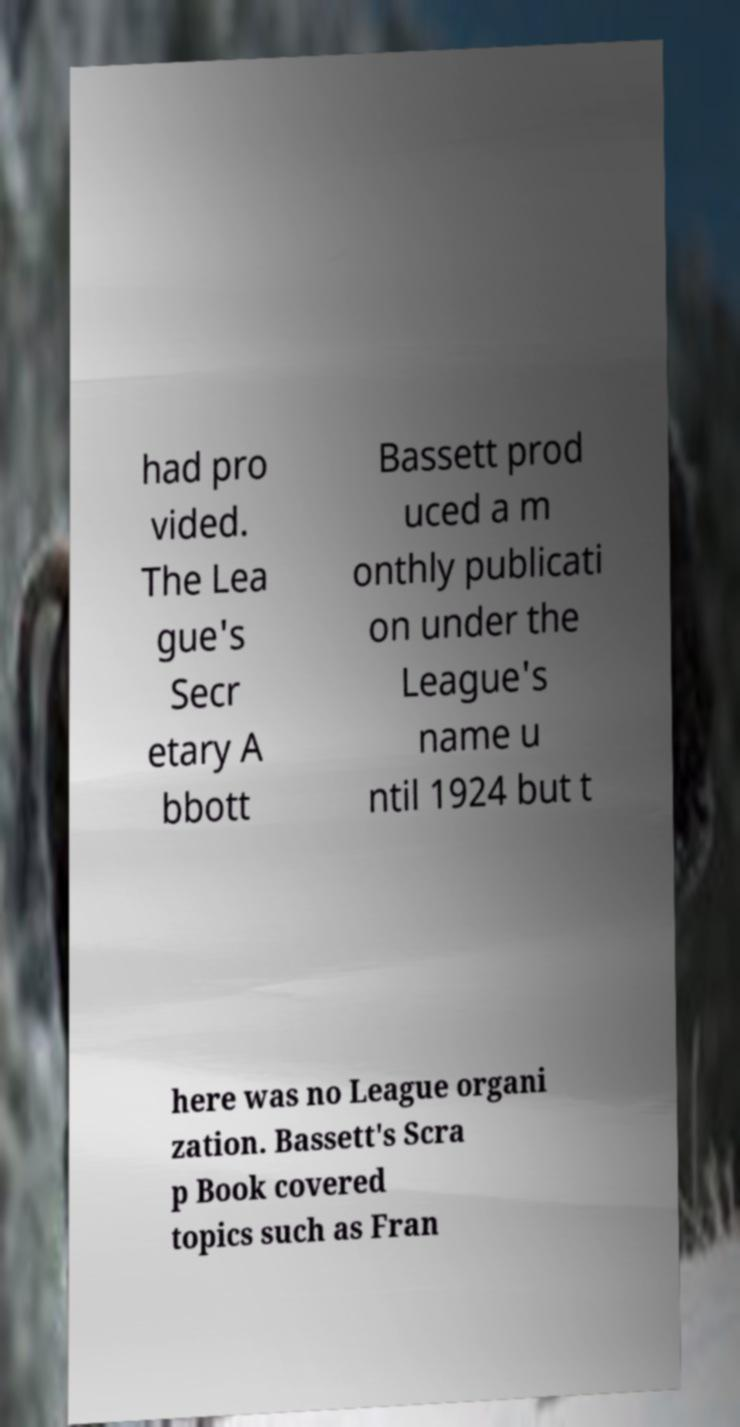Please identify and transcribe the text found in this image. had pro vided. The Lea gue's Secr etary A bbott Bassett prod uced a m onthly publicati on under the League's name u ntil 1924 but t here was no League organi zation. Bassett's Scra p Book covered topics such as Fran 